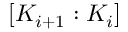Convert formula to latex. <formula><loc_0><loc_0><loc_500><loc_500>[ K _ { i + 1 } \colon K _ { i } ]</formula> 